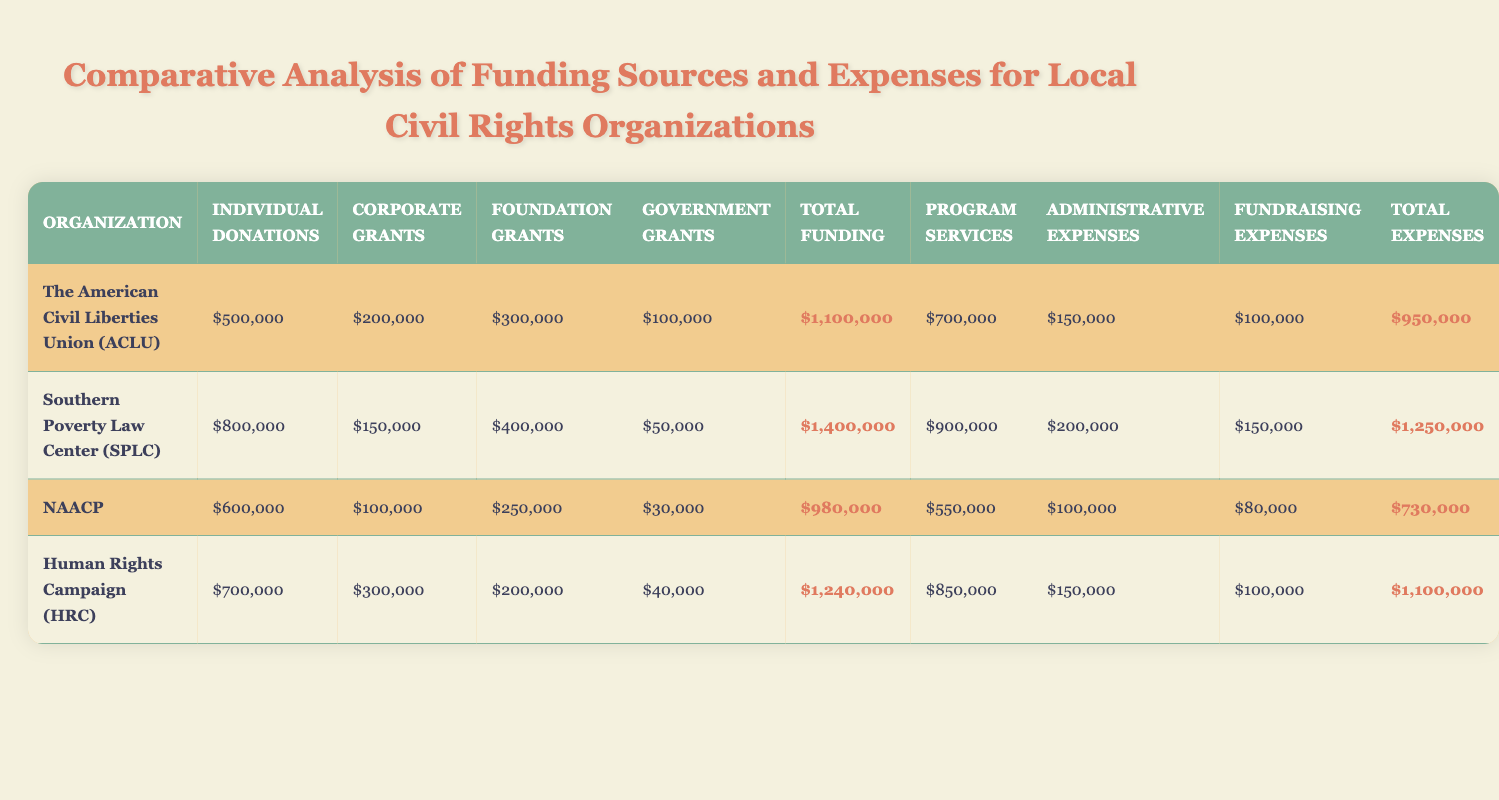What is the total funding for the NAACP? According to the table under the NAACP row, the total funding amount listed is $980,000.
Answer: $980,000 Which organization has the highest total expenses? The organization with the highest total expenses is the Southern Poverty Law Center (SPLC), which has total expenses of $1,250,000 as indicated in the table.
Answer: Southern Poverty Law Center (SPLC) What is the difference between total funding and total expenses for the Human Rights Campaign? The total funding for the Human Rights Campaign is $1,240,000, and their total expenses are $1,100,000. The difference is calculated as $1,240,000 - $1,100,000 = $140,000.
Answer: $140,000 Did the ACLU receive more funding from individual donations than from corporate grants? Yes, the ACLU received $500,000 from individual donations and $200,000 from corporate grants, thus making individual donations greater.
Answer: Yes Which organization spends the most on program services, and what is that amount? The organization that spends the most on program services is the Southern Poverty Law Center (SPLC), which spends $900,000 as highlighted in the table.
Answer: Southern Poverty Law Center (SPLC), $900,000 What percentage of total funding for the NAACP comes from individual donations? The NAACP's total funding is $980,000, with individual donations being $600,000. The percentage is calculated as ($600,000 / $980,000) * 100 = 61.22%.
Answer: 61.22% How much more does the SPLC spend on administrative expenses compared to the ACLU? The SPLC spends $200,000 on administrative expenses, while the ACLU spends $150,000. The difference in spending is $200,000 - $150,000 = $50,000.
Answer: $50,000 Which organization has the least funding from government grants, and how much is it? The organization with the least funding from government grants is the NAACP, which received $30,000 according to the funding sources in the table.
Answer: NAACP, $30,000 What is the total funding across all organizations? The total funding for all organizations can be computed by adding the total funding of each organization: $1,100,000 (ACLU) + $1,400,000 (SPLC) + $980,000 (NAACP) + $1,240,000 (HRC) = $4,720,000.
Answer: $4,720,000 